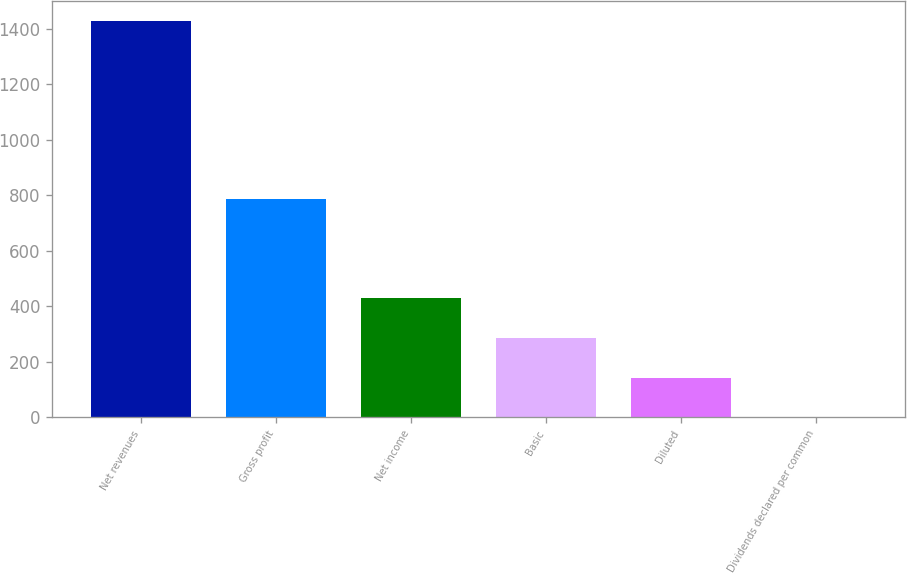Convert chart to OTSL. <chart><loc_0><loc_0><loc_500><loc_500><bar_chart><fcel>Net revenues<fcel>Gross profit<fcel>Net income<fcel>Basic<fcel>Diluted<fcel>Dividends declared per common<nl><fcel>1428.9<fcel>788.2<fcel>428.72<fcel>285.83<fcel>142.94<fcel>0.05<nl></chart> 